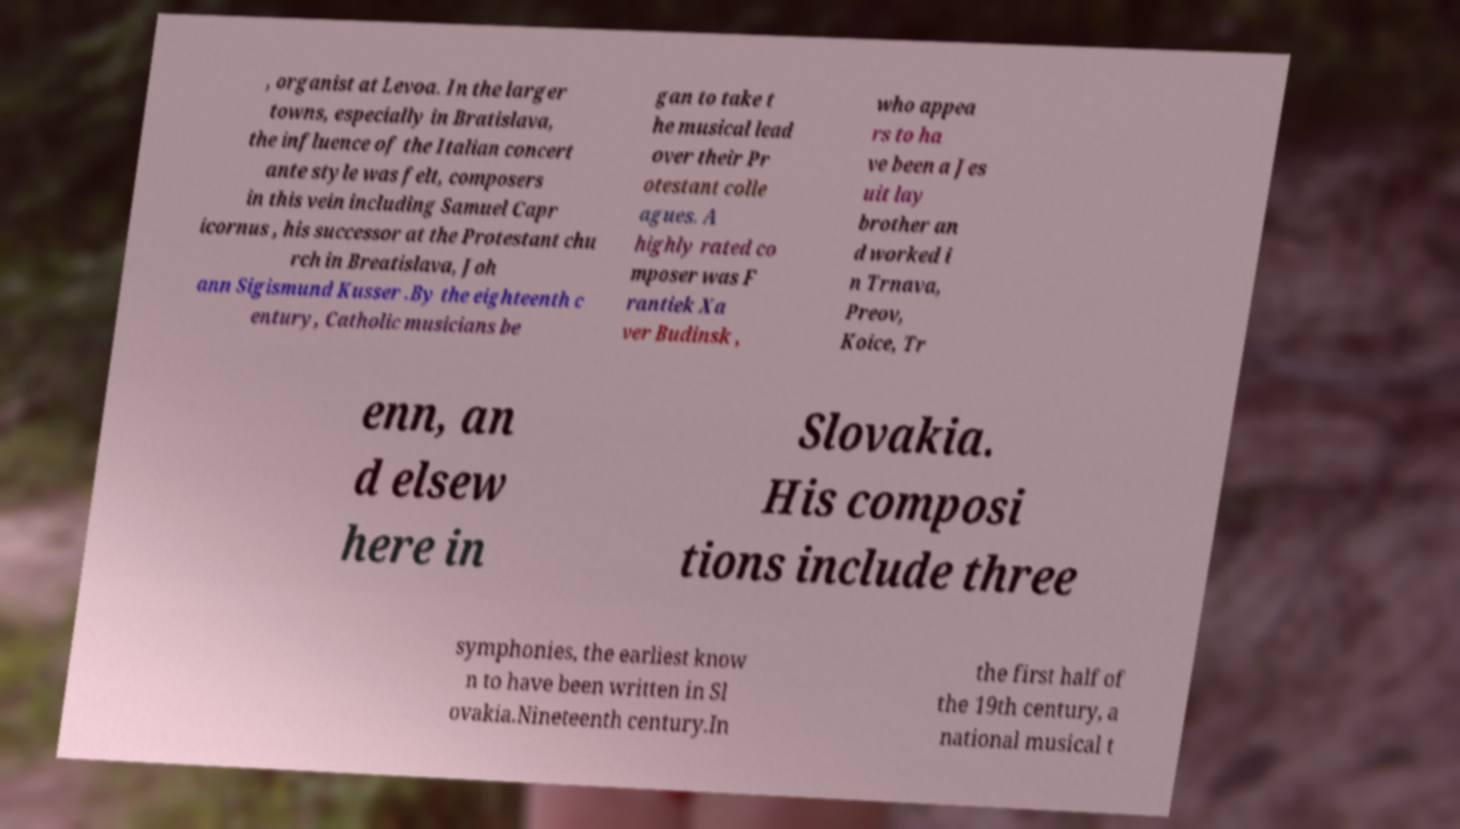There's text embedded in this image that I need extracted. Can you transcribe it verbatim? , organist at Levoa. In the larger towns, especially in Bratislava, the influence of the Italian concert ante style was felt, composers in this vein including Samuel Capr icornus , his successor at the Protestant chu rch in Breatislava, Joh ann Sigismund Kusser .By the eighteenth c entury, Catholic musicians be gan to take t he musical lead over their Pr otestant colle agues. A highly rated co mposer was F rantiek Xa ver Budinsk , who appea rs to ha ve been a Jes uit lay brother an d worked i n Trnava, Preov, Koice, Tr enn, an d elsew here in Slovakia. His composi tions include three symphonies, the earliest know n to have been written in Sl ovakia.Nineteenth century.In the first half of the 19th century, a national musical t 